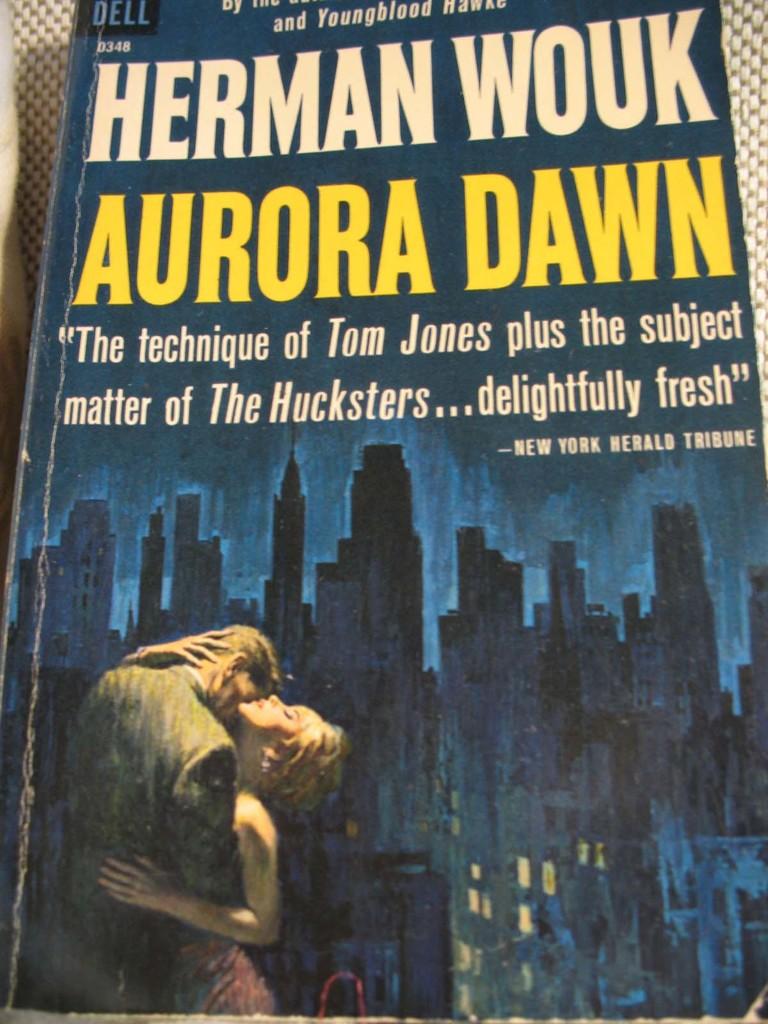What is being quoted under the books title?
Offer a terse response. The technique of tom jones plus the subject matter of the hucksters...delightfully fresh. 